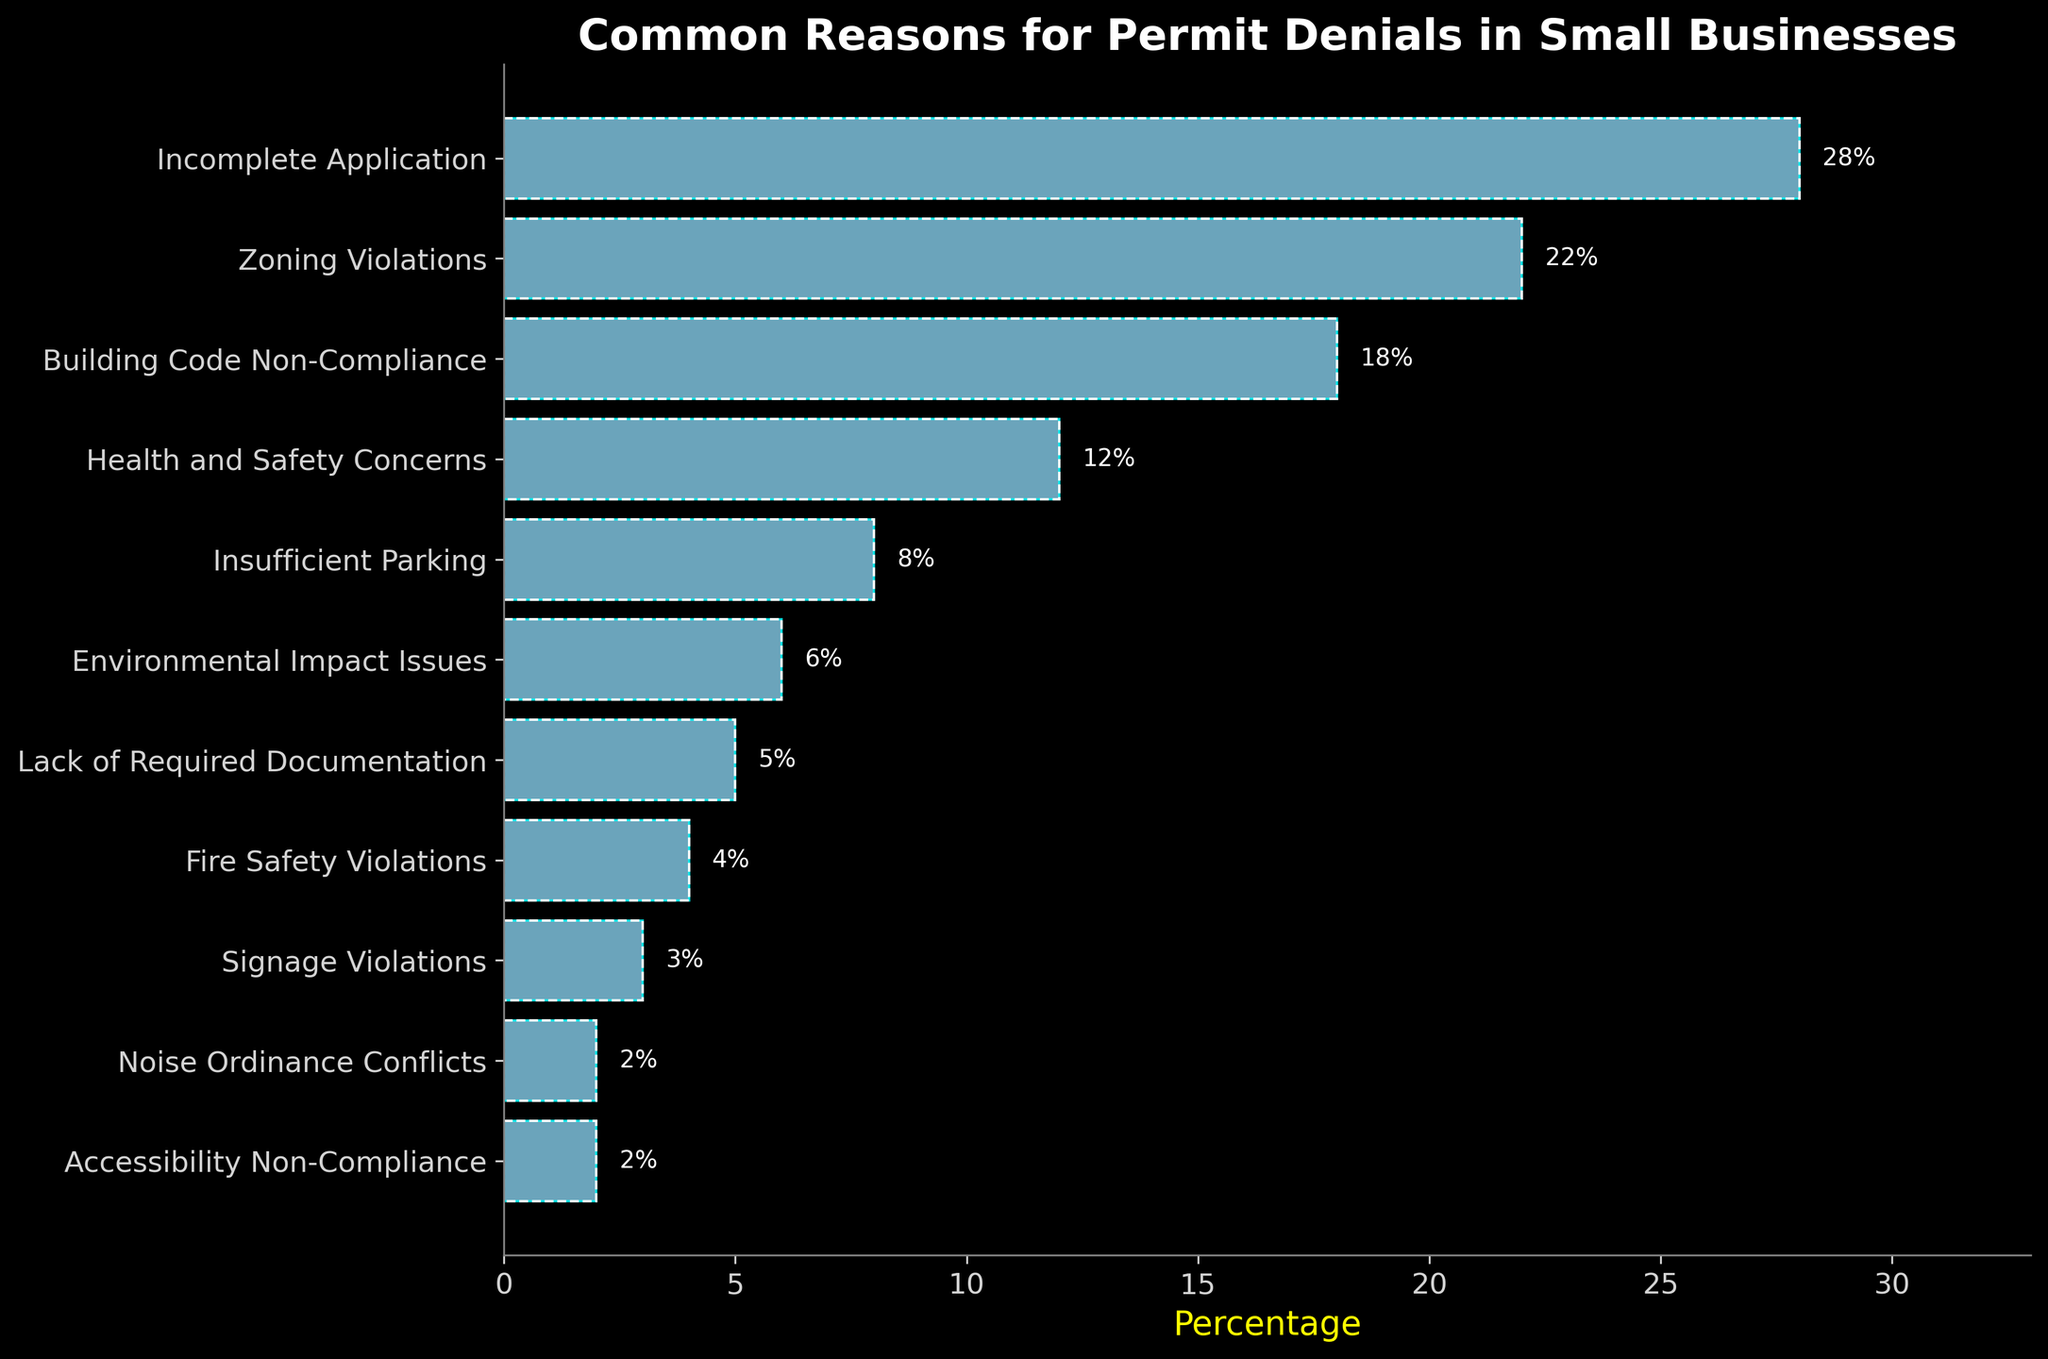Which reason has the highest percentage for permit denials? The tallest bar represents the highest percentage, which is for "Incomplete Application" at 28%.
Answer: Incomplete Application What is the combined percentage of "Zoning Violations" and "Building Code Non-Compliance"? Add the percentages for "Zoning Violations" (22%) and "Building Code Non-Compliance" (18%). This gives 22% + 18% = 40%.
Answer: 40% Is "Health and Safety Concerns" responsible for a greater percentage of denials than "Insufficient Parking"? Compare the percentage of "Health and Safety Concerns" (12%) with that of "Insufficient Parking" (8%). Since 12% > 8%, "Health and Safety Concerns" has a greater percentage.
Answer: Yes Which reasons for permit denials have percentages below 5%? Look for bars with lengths representing percentages below 5%. These are "Lack of Required Documentation" (5%), "Fire Safety Violations" (4%), "Signage Violations" (3%), "Noise Ordinance Conflicts" (2%), and "Accessibility Non-Compliance" (2%).
Answer: Lack of Required Documentation, Fire Safety Violations, Signage Violations, Noise Ordinance Conflicts, Accessibility Non-Compliance By how much does the percentage of "Building Code Non-Compliance" exceed that of "Environmental Impact Issues"? Subtract the percentage of "Environmental Impact Issues" (6%) from "Building Code Non-Compliance" (18%). This gives 18% - 6% = 12%.
Answer: 12% Can you identify any reasons that are equally significant in causing permit denials? Compare the percentages of all reasons to identify any that are equal. "Noise Ordinance Conflicts" and "Accessibility Non-Compliance" both have a 2% denial percentage.
Answer: Noise Ordinance Conflicts and Accessibility Non-Compliance If the percentage for "Incomplete Application" was reduced by 10%, what would the new percentage be? Subtract 10% from the current percentage of "Incomplete Application" (28%). This gives 28% - 10% = 18%.
Answer: 18% What is the visual appearance of the bar representing "Health and Safety Concerns"? Describe the visual attributes of the bar for "Health and Safety Concerns". It is a horizontal light blue bar with text "12%" displayed to the right of the bar.
Answer: Horizontal light blue bar with "12%" text to the right How many reasons have percentages that are 10% or higher? Count the bars with a length representing percentages 10% or higher. These reasons are "Incomplete Application" (28%), "Zoning Violations" (22%), "Building Code Non-Compliance" (18%), and "Health and Safety Concerns" (12%). There are 4 such reasons.
Answer: 4 What is the difference in percentage between the top reason and the lowest reason for permit denials? Subtract the percentage of the lowest reason "Accessibility Non-Compliance" (2%) from the highest reason "Incomplete Application" (28%). This gives 28% - 2% = 26%.
Answer: 26% 